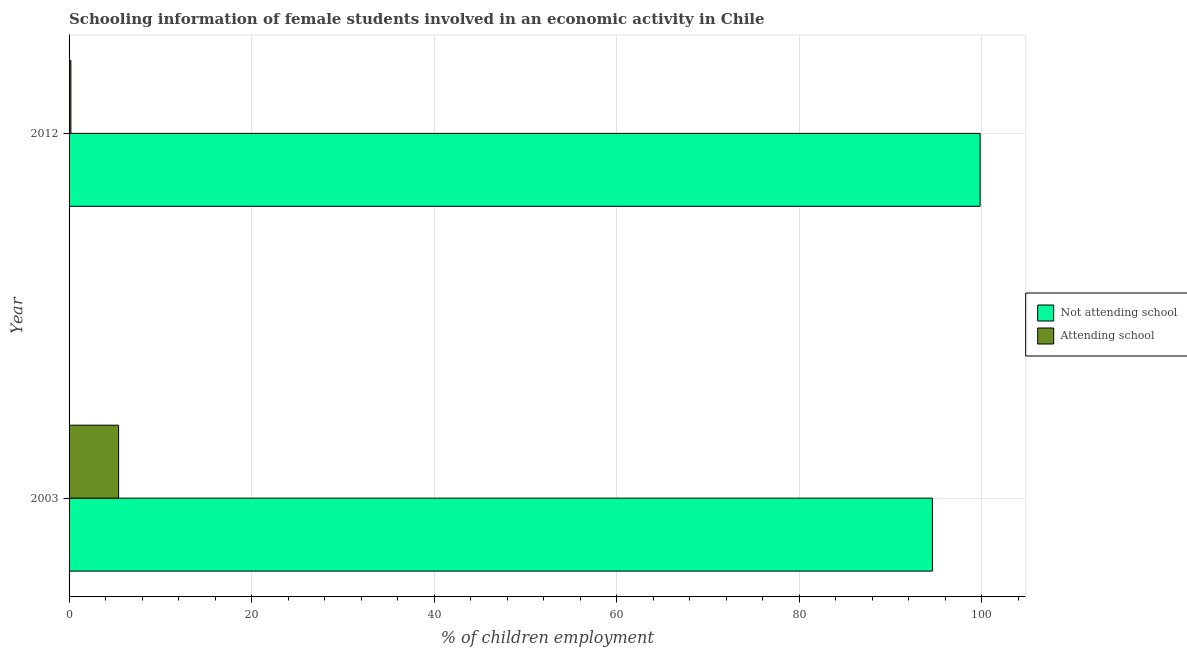How many different coloured bars are there?
Provide a succinct answer. 2. How many groups of bars are there?
Your response must be concise. 2. How many bars are there on the 1st tick from the top?
Give a very brief answer. 2. How many bars are there on the 2nd tick from the bottom?
Offer a terse response. 2. In how many cases, is the number of bars for a given year not equal to the number of legend labels?
Offer a very short reply. 0. What is the percentage of employed females who are not attending school in 2012?
Ensure brevity in your answer.  99.8. Across all years, what is the maximum percentage of employed females who are not attending school?
Provide a succinct answer. 99.8. In which year was the percentage of employed females who are not attending school maximum?
Your answer should be very brief. 2012. In which year was the percentage of employed females who are attending school minimum?
Your answer should be very brief. 2012. What is the total percentage of employed females who are not attending school in the graph?
Your response must be concise. 194.37. What is the difference between the percentage of employed females who are attending school in 2003 and that in 2012?
Your answer should be compact. 5.23. What is the difference between the percentage of employed females who are attending school in 2003 and the percentage of employed females who are not attending school in 2012?
Provide a succinct answer. -94.37. What is the average percentage of employed females who are not attending school per year?
Offer a terse response. 97.19. In the year 2003, what is the difference between the percentage of employed females who are not attending school and percentage of employed females who are attending school?
Ensure brevity in your answer.  89.15. What is the ratio of the percentage of employed females who are not attending school in 2003 to that in 2012?
Offer a very short reply. 0.95. Is the difference between the percentage of employed females who are attending school in 2003 and 2012 greater than the difference between the percentage of employed females who are not attending school in 2003 and 2012?
Give a very brief answer. Yes. What does the 2nd bar from the top in 2012 represents?
Your answer should be very brief. Not attending school. What does the 2nd bar from the bottom in 2003 represents?
Your answer should be very brief. Attending school. Are all the bars in the graph horizontal?
Provide a succinct answer. Yes. Are the values on the major ticks of X-axis written in scientific E-notation?
Offer a terse response. No. Does the graph contain any zero values?
Make the answer very short. No. How many legend labels are there?
Keep it short and to the point. 2. What is the title of the graph?
Offer a very short reply. Schooling information of female students involved in an economic activity in Chile. What is the label or title of the X-axis?
Give a very brief answer. % of children employment. What is the label or title of the Y-axis?
Provide a short and direct response. Year. What is the % of children employment in Not attending school in 2003?
Give a very brief answer. 94.57. What is the % of children employment of Attending school in 2003?
Keep it short and to the point. 5.43. What is the % of children employment in Not attending school in 2012?
Your answer should be very brief. 99.8. What is the % of children employment of Attending school in 2012?
Ensure brevity in your answer.  0.2. Across all years, what is the maximum % of children employment of Not attending school?
Give a very brief answer. 99.8. Across all years, what is the maximum % of children employment in Attending school?
Provide a short and direct response. 5.43. Across all years, what is the minimum % of children employment of Not attending school?
Give a very brief answer. 94.57. Across all years, what is the minimum % of children employment of Attending school?
Give a very brief answer. 0.2. What is the total % of children employment of Not attending school in the graph?
Offer a very short reply. 194.37. What is the total % of children employment in Attending school in the graph?
Offer a very short reply. 5.63. What is the difference between the % of children employment in Not attending school in 2003 and that in 2012?
Keep it short and to the point. -5.23. What is the difference between the % of children employment in Attending school in 2003 and that in 2012?
Provide a succinct answer. 5.23. What is the difference between the % of children employment in Not attending school in 2003 and the % of children employment in Attending school in 2012?
Your answer should be compact. 94.37. What is the average % of children employment in Not attending school per year?
Make the answer very short. 97.19. What is the average % of children employment in Attending school per year?
Provide a short and direct response. 2.81. In the year 2003, what is the difference between the % of children employment of Not attending school and % of children employment of Attending school?
Your response must be concise. 89.15. In the year 2012, what is the difference between the % of children employment in Not attending school and % of children employment in Attending school?
Offer a very short reply. 99.6. What is the ratio of the % of children employment in Not attending school in 2003 to that in 2012?
Make the answer very short. 0.95. What is the ratio of the % of children employment in Attending school in 2003 to that in 2012?
Your answer should be very brief. 27.13. What is the difference between the highest and the second highest % of children employment in Not attending school?
Offer a terse response. 5.23. What is the difference between the highest and the second highest % of children employment in Attending school?
Your response must be concise. 5.23. What is the difference between the highest and the lowest % of children employment in Not attending school?
Your answer should be very brief. 5.23. What is the difference between the highest and the lowest % of children employment in Attending school?
Offer a terse response. 5.23. 